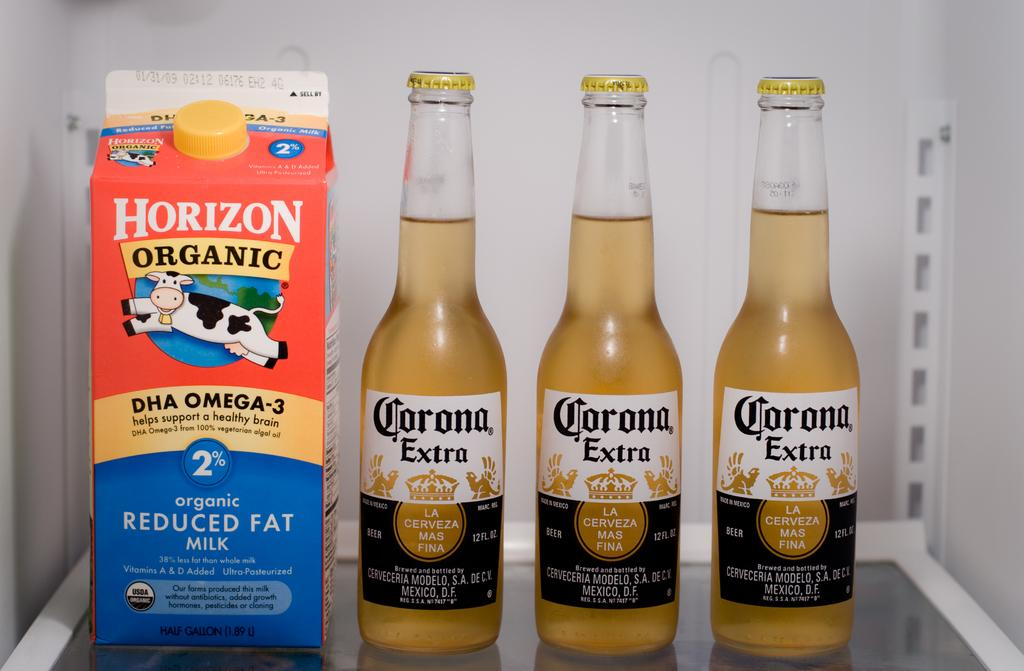<image>
Create a compact narrative representing the image presented. A bottle of Horizon organic milk sits next to three bottles of Corona beer. 